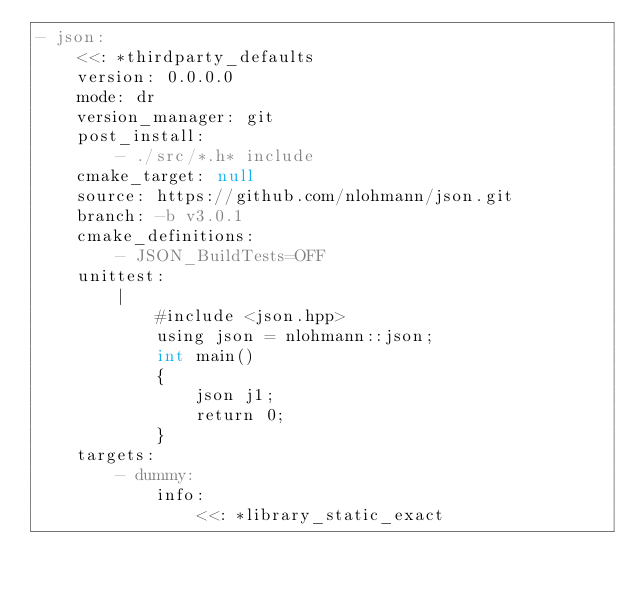<code> <loc_0><loc_0><loc_500><loc_500><_YAML_>- json:
    <<: *thirdparty_defaults
    version: 0.0.0.0
    mode: dr
    version_manager: git
    post_install:
        - ./src/*.h* include
    cmake_target: null
    source: https://github.com/nlohmann/json.git
    branch: -b v3.0.1
    cmake_definitions:
        - JSON_BuildTests=OFF
    unittest:
        |
            #include <json.hpp>
            using json = nlohmann::json;
            int main()
            {
                json j1;
                return 0;
            }
    targets:
        - dummy:
            info:
                <<: *library_static_exact

</code> 